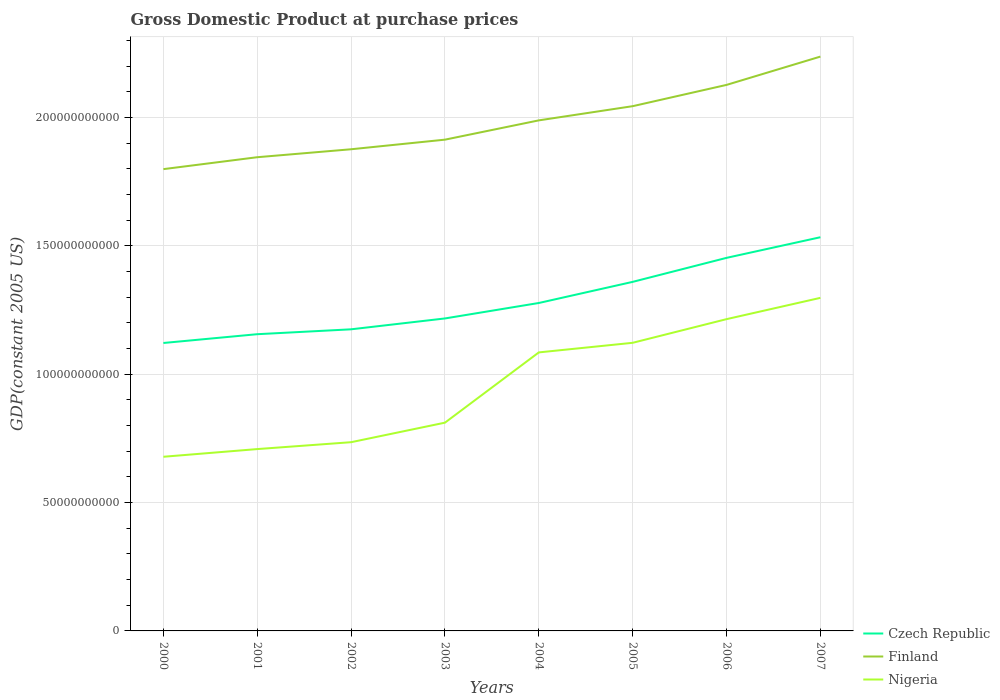How many different coloured lines are there?
Your answer should be compact. 3. Is the number of lines equal to the number of legend labels?
Keep it short and to the point. Yes. Across all years, what is the maximum GDP at purchase prices in Czech Republic?
Provide a short and direct response. 1.12e+11. In which year was the GDP at purchase prices in Nigeria maximum?
Give a very brief answer. 2000. What is the total GDP at purchase prices in Finland in the graph?
Offer a terse response. -3.24e+1. What is the difference between the highest and the second highest GDP at purchase prices in Nigeria?
Your response must be concise. 6.19e+1. Is the GDP at purchase prices in Czech Republic strictly greater than the GDP at purchase prices in Nigeria over the years?
Your answer should be very brief. No. How many lines are there?
Keep it short and to the point. 3. What is the difference between two consecutive major ticks on the Y-axis?
Offer a terse response. 5.00e+1. Are the values on the major ticks of Y-axis written in scientific E-notation?
Your answer should be very brief. No. Does the graph contain grids?
Offer a terse response. Yes. Where does the legend appear in the graph?
Ensure brevity in your answer.  Bottom right. How are the legend labels stacked?
Your response must be concise. Vertical. What is the title of the graph?
Provide a short and direct response. Gross Domestic Product at purchase prices. What is the label or title of the Y-axis?
Give a very brief answer. GDP(constant 2005 US). What is the GDP(constant 2005 US) of Czech Republic in 2000?
Provide a succinct answer. 1.12e+11. What is the GDP(constant 2005 US) of Finland in 2000?
Ensure brevity in your answer.  1.80e+11. What is the GDP(constant 2005 US) of Nigeria in 2000?
Keep it short and to the point. 6.79e+1. What is the GDP(constant 2005 US) of Czech Republic in 2001?
Ensure brevity in your answer.  1.16e+11. What is the GDP(constant 2005 US) of Finland in 2001?
Your answer should be compact. 1.85e+11. What is the GDP(constant 2005 US) in Nigeria in 2001?
Offer a very short reply. 7.08e+1. What is the GDP(constant 2005 US) of Czech Republic in 2002?
Offer a terse response. 1.18e+11. What is the GDP(constant 2005 US) of Finland in 2002?
Give a very brief answer. 1.88e+11. What is the GDP(constant 2005 US) of Nigeria in 2002?
Ensure brevity in your answer.  7.35e+1. What is the GDP(constant 2005 US) in Czech Republic in 2003?
Offer a very short reply. 1.22e+11. What is the GDP(constant 2005 US) in Finland in 2003?
Your answer should be compact. 1.91e+11. What is the GDP(constant 2005 US) in Nigeria in 2003?
Your answer should be compact. 8.11e+1. What is the GDP(constant 2005 US) in Czech Republic in 2004?
Ensure brevity in your answer.  1.28e+11. What is the GDP(constant 2005 US) of Finland in 2004?
Make the answer very short. 1.99e+11. What is the GDP(constant 2005 US) of Nigeria in 2004?
Your answer should be very brief. 1.09e+11. What is the GDP(constant 2005 US) in Czech Republic in 2005?
Provide a succinct answer. 1.36e+11. What is the GDP(constant 2005 US) of Finland in 2005?
Your answer should be compact. 2.04e+11. What is the GDP(constant 2005 US) of Nigeria in 2005?
Offer a very short reply. 1.12e+11. What is the GDP(constant 2005 US) in Czech Republic in 2006?
Provide a short and direct response. 1.45e+11. What is the GDP(constant 2005 US) of Finland in 2006?
Your response must be concise. 2.13e+11. What is the GDP(constant 2005 US) of Nigeria in 2006?
Ensure brevity in your answer.  1.21e+11. What is the GDP(constant 2005 US) of Czech Republic in 2007?
Keep it short and to the point. 1.53e+11. What is the GDP(constant 2005 US) in Finland in 2007?
Provide a succinct answer. 2.24e+11. What is the GDP(constant 2005 US) of Nigeria in 2007?
Provide a succinct answer. 1.30e+11. Across all years, what is the maximum GDP(constant 2005 US) in Czech Republic?
Make the answer very short. 1.53e+11. Across all years, what is the maximum GDP(constant 2005 US) in Finland?
Keep it short and to the point. 2.24e+11. Across all years, what is the maximum GDP(constant 2005 US) of Nigeria?
Ensure brevity in your answer.  1.30e+11. Across all years, what is the minimum GDP(constant 2005 US) in Czech Republic?
Provide a succinct answer. 1.12e+11. Across all years, what is the minimum GDP(constant 2005 US) in Finland?
Offer a terse response. 1.80e+11. Across all years, what is the minimum GDP(constant 2005 US) in Nigeria?
Keep it short and to the point. 6.79e+1. What is the total GDP(constant 2005 US) of Czech Republic in the graph?
Provide a short and direct response. 1.03e+12. What is the total GDP(constant 2005 US) of Finland in the graph?
Provide a succinct answer. 1.58e+12. What is the total GDP(constant 2005 US) of Nigeria in the graph?
Offer a very short reply. 7.65e+11. What is the difference between the GDP(constant 2005 US) of Czech Republic in 2000 and that in 2001?
Your answer should be very brief. -3.42e+09. What is the difference between the GDP(constant 2005 US) of Finland in 2000 and that in 2001?
Make the answer very short. -4.64e+09. What is the difference between the GDP(constant 2005 US) in Nigeria in 2000 and that in 2001?
Give a very brief answer. -2.99e+09. What is the difference between the GDP(constant 2005 US) of Czech Republic in 2000 and that in 2002?
Provide a short and direct response. -5.33e+09. What is the difference between the GDP(constant 2005 US) of Finland in 2000 and that in 2002?
Make the answer very short. -7.74e+09. What is the difference between the GDP(constant 2005 US) in Nigeria in 2000 and that in 2002?
Provide a succinct answer. -5.67e+09. What is the difference between the GDP(constant 2005 US) of Czech Republic in 2000 and that in 2003?
Give a very brief answer. -9.56e+09. What is the difference between the GDP(constant 2005 US) of Finland in 2000 and that in 2003?
Offer a very short reply. -1.15e+1. What is the difference between the GDP(constant 2005 US) in Nigeria in 2000 and that in 2003?
Keep it short and to the point. -1.33e+1. What is the difference between the GDP(constant 2005 US) in Czech Republic in 2000 and that in 2004?
Provide a short and direct response. -1.56e+1. What is the difference between the GDP(constant 2005 US) of Finland in 2000 and that in 2004?
Keep it short and to the point. -1.90e+1. What is the difference between the GDP(constant 2005 US) of Nigeria in 2000 and that in 2004?
Your answer should be very brief. -4.07e+1. What is the difference between the GDP(constant 2005 US) of Czech Republic in 2000 and that in 2005?
Your answer should be compact. -2.38e+1. What is the difference between the GDP(constant 2005 US) in Finland in 2000 and that in 2005?
Ensure brevity in your answer.  -2.45e+1. What is the difference between the GDP(constant 2005 US) of Nigeria in 2000 and that in 2005?
Provide a short and direct response. -4.44e+1. What is the difference between the GDP(constant 2005 US) in Czech Republic in 2000 and that in 2006?
Ensure brevity in your answer.  -3.32e+1. What is the difference between the GDP(constant 2005 US) of Finland in 2000 and that in 2006?
Offer a very short reply. -3.28e+1. What is the difference between the GDP(constant 2005 US) of Nigeria in 2000 and that in 2006?
Keep it short and to the point. -5.36e+1. What is the difference between the GDP(constant 2005 US) of Czech Republic in 2000 and that in 2007?
Offer a very short reply. -4.12e+1. What is the difference between the GDP(constant 2005 US) in Finland in 2000 and that in 2007?
Your answer should be compact. -4.38e+1. What is the difference between the GDP(constant 2005 US) of Nigeria in 2000 and that in 2007?
Your response must be concise. -6.19e+1. What is the difference between the GDP(constant 2005 US) of Czech Republic in 2001 and that in 2002?
Keep it short and to the point. -1.90e+09. What is the difference between the GDP(constant 2005 US) in Finland in 2001 and that in 2002?
Provide a short and direct response. -3.10e+09. What is the difference between the GDP(constant 2005 US) of Nigeria in 2001 and that in 2002?
Ensure brevity in your answer.  -2.68e+09. What is the difference between the GDP(constant 2005 US) in Czech Republic in 2001 and that in 2003?
Offer a terse response. -6.14e+09. What is the difference between the GDP(constant 2005 US) of Finland in 2001 and that in 2003?
Ensure brevity in your answer.  -6.84e+09. What is the difference between the GDP(constant 2005 US) of Nigeria in 2001 and that in 2003?
Provide a succinct answer. -1.03e+1. What is the difference between the GDP(constant 2005 US) of Czech Republic in 2001 and that in 2004?
Offer a terse response. -1.22e+1. What is the difference between the GDP(constant 2005 US) in Finland in 2001 and that in 2004?
Make the answer very short. -1.44e+1. What is the difference between the GDP(constant 2005 US) in Nigeria in 2001 and that in 2004?
Ensure brevity in your answer.  -3.77e+1. What is the difference between the GDP(constant 2005 US) of Czech Republic in 2001 and that in 2005?
Your answer should be compact. -2.04e+1. What is the difference between the GDP(constant 2005 US) in Finland in 2001 and that in 2005?
Your response must be concise. -1.99e+1. What is the difference between the GDP(constant 2005 US) of Nigeria in 2001 and that in 2005?
Keep it short and to the point. -4.14e+1. What is the difference between the GDP(constant 2005 US) of Czech Republic in 2001 and that in 2006?
Ensure brevity in your answer.  -2.97e+1. What is the difference between the GDP(constant 2005 US) in Finland in 2001 and that in 2006?
Offer a very short reply. -2.82e+1. What is the difference between the GDP(constant 2005 US) of Nigeria in 2001 and that in 2006?
Offer a very short reply. -5.06e+1. What is the difference between the GDP(constant 2005 US) of Czech Republic in 2001 and that in 2007?
Make the answer very short. -3.78e+1. What is the difference between the GDP(constant 2005 US) in Finland in 2001 and that in 2007?
Ensure brevity in your answer.  -3.92e+1. What is the difference between the GDP(constant 2005 US) of Nigeria in 2001 and that in 2007?
Your answer should be very brief. -5.89e+1. What is the difference between the GDP(constant 2005 US) of Czech Republic in 2002 and that in 2003?
Make the answer very short. -4.23e+09. What is the difference between the GDP(constant 2005 US) of Finland in 2002 and that in 2003?
Provide a succinct answer. -3.74e+09. What is the difference between the GDP(constant 2005 US) in Nigeria in 2002 and that in 2003?
Provide a succinct answer. -7.61e+09. What is the difference between the GDP(constant 2005 US) of Czech Republic in 2002 and that in 2004?
Provide a short and direct response. -1.03e+1. What is the difference between the GDP(constant 2005 US) of Finland in 2002 and that in 2004?
Offer a terse response. -1.13e+1. What is the difference between the GDP(constant 2005 US) of Nigeria in 2002 and that in 2004?
Make the answer very short. -3.50e+1. What is the difference between the GDP(constant 2005 US) in Czech Republic in 2002 and that in 2005?
Provide a short and direct response. -1.85e+1. What is the difference between the GDP(constant 2005 US) in Finland in 2002 and that in 2005?
Offer a very short reply. -1.68e+1. What is the difference between the GDP(constant 2005 US) of Nigeria in 2002 and that in 2005?
Make the answer very short. -3.87e+1. What is the difference between the GDP(constant 2005 US) of Czech Republic in 2002 and that in 2006?
Keep it short and to the point. -2.78e+1. What is the difference between the GDP(constant 2005 US) in Finland in 2002 and that in 2006?
Give a very brief answer. -2.51e+1. What is the difference between the GDP(constant 2005 US) in Nigeria in 2002 and that in 2006?
Your response must be concise. -4.79e+1. What is the difference between the GDP(constant 2005 US) in Czech Republic in 2002 and that in 2007?
Your answer should be compact. -3.59e+1. What is the difference between the GDP(constant 2005 US) of Finland in 2002 and that in 2007?
Ensure brevity in your answer.  -3.61e+1. What is the difference between the GDP(constant 2005 US) in Nigeria in 2002 and that in 2007?
Offer a very short reply. -5.62e+1. What is the difference between the GDP(constant 2005 US) in Czech Republic in 2003 and that in 2004?
Provide a short and direct response. -6.02e+09. What is the difference between the GDP(constant 2005 US) in Finland in 2003 and that in 2004?
Your response must be concise. -7.51e+09. What is the difference between the GDP(constant 2005 US) in Nigeria in 2003 and that in 2004?
Your response must be concise. -2.74e+1. What is the difference between the GDP(constant 2005 US) in Czech Republic in 2003 and that in 2005?
Keep it short and to the point. -1.43e+1. What is the difference between the GDP(constant 2005 US) in Finland in 2003 and that in 2005?
Your response must be concise. -1.30e+1. What is the difference between the GDP(constant 2005 US) of Nigeria in 2003 and that in 2005?
Your response must be concise. -3.11e+1. What is the difference between the GDP(constant 2005 US) in Czech Republic in 2003 and that in 2006?
Provide a short and direct response. -2.36e+1. What is the difference between the GDP(constant 2005 US) in Finland in 2003 and that in 2006?
Your answer should be compact. -2.13e+1. What is the difference between the GDP(constant 2005 US) in Nigeria in 2003 and that in 2006?
Provide a short and direct response. -4.03e+1. What is the difference between the GDP(constant 2005 US) in Czech Republic in 2003 and that in 2007?
Offer a very short reply. -3.16e+1. What is the difference between the GDP(constant 2005 US) in Finland in 2003 and that in 2007?
Offer a terse response. -3.24e+1. What is the difference between the GDP(constant 2005 US) in Nigeria in 2003 and that in 2007?
Make the answer very short. -4.86e+1. What is the difference between the GDP(constant 2005 US) of Czech Republic in 2004 and that in 2005?
Your answer should be compact. -8.23e+09. What is the difference between the GDP(constant 2005 US) of Finland in 2004 and that in 2005?
Provide a short and direct response. -5.53e+09. What is the difference between the GDP(constant 2005 US) of Nigeria in 2004 and that in 2005?
Your answer should be very brief. -3.74e+09. What is the difference between the GDP(constant 2005 US) of Czech Republic in 2004 and that in 2006?
Ensure brevity in your answer.  -1.76e+1. What is the difference between the GDP(constant 2005 US) in Finland in 2004 and that in 2006?
Make the answer very short. -1.38e+1. What is the difference between the GDP(constant 2005 US) in Nigeria in 2004 and that in 2006?
Keep it short and to the point. -1.30e+1. What is the difference between the GDP(constant 2005 US) of Czech Republic in 2004 and that in 2007?
Give a very brief answer. -2.56e+1. What is the difference between the GDP(constant 2005 US) in Finland in 2004 and that in 2007?
Your response must be concise. -2.48e+1. What is the difference between the GDP(constant 2005 US) in Nigeria in 2004 and that in 2007?
Your response must be concise. -2.12e+1. What is the difference between the GDP(constant 2005 US) in Czech Republic in 2005 and that in 2006?
Ensure brevity in your answer.  -9.35e+09. What is the difference between the GDP(constant 2005 US) of Finland in 2005 and that in 2006?
Provide a succinct answer. -8.29e+09. What is the difference between the GDP(constant 2005 US) of Nigeria in 2005 and that in 2006?
Your response must be concise. -9.22e+09. What is the difference between the GDP(constant 2005 US) of Czech Republic in 2005 and that in 2007?
Offer a very short reply. -1.74e+1. What is the difference between the GDP(constant 2005 US) in Finland in 2005 and that in 2007?
Your response must be concise. -1.93e+1. What is the difference between the GDP(constant 2005 US) in Nigeria in 2005 and that in 2007?
Provide a short and direct response. -1.75e+1. What is the difference between the GDP(constant 2005 US) of Czech Republic in 2006 and that in 2007?
Offer a terse response. -8.04e+09. What is the difference between the GDP(constant 2005 US) of Finland in 2006 and that in 2007?
Give a very brief answer. -1.10e+1. What is the difference between the GDP(constant 2005 US) in Nigeria in 2006 and that in 2007?
Give a very brief answer. -8.29e+09. What is the difference between the GDP(constant 2005 US) in Czech Republic in 2000 and the GDP(constant 2005 US) in Finland in 2001?
Give a very brief answer. -7.24e+1. What is the difference between the GDP(constant 2005 US) in Czech Republic in 2000 and the GDP(constant 2005 US) in Nigeria in 2001?
Your answer should be very brief. 4.13e+1. What is the difference between the GDP(constant 2005 US) of Finland in 2000 and the GDP(constant 2005 US) of Nigeria in 2001?
Offer a very short reply. 1.09e+11. What is the difference between the GDP(constant 2005 US) in Czech Republic in 2000 and the GDP(constant 2005 US) in Finland in 2002?
Give a very brief answer. -7.55e+1. What is the difference between the GDP(constant 2005 US) of Czech Republic in 2000 and the GDP(constant 2005 US) of Nigeria in 2002?
Give a very brief answer. 3.87e+1. What is the difference between the GDP(constant 2005 US) in Finland in 2000 and the GDP(constant 2005 US) in Nigeria in 2002?
Provide a short and direct response. 1.06e+11. What is the difference between the GDP(constant 2005 US) in Czech Republic in 2000 and the GDP(constant 2005 US) in Finland in 2003?
Ensure brevity in your answer.  -7.92e+1. What is the difference between the GDP(constant 2005 US) of Czech Republic in 2000 and the GDP(constant 2005 US) of Nigeria in 2003?
Your answer should be very brief. 3.10e+1. What is the difference between the GDP(constant 2005 US) in Finland in 2000 and the GDP(constant 2005 US) in Nigeria in 2003?
Your answer should be very brief. 9.88e+1. What is the difference between the GDP(constant 2005 US) of Czech Republic in 2000 and the GDP(constant 2005 US) of Finland in 2004?
Your answer should be compact. -8.67e+1. What is the difference between the GDP(constant 2005 US) in Czech Republic in 2000 and the GDP(constant 2005 US) in Nigeria in 2004?
Ensure brevity in your answer.  3.67e+09. What is the difference between the GDP(constant 2005 US) in Finland in 2000 and the GDP(constant 2005 US) in Nigeria in 2004?
Your response must be concise. 7.14e+1. What is the difference between the GDP(constant 2005 US) of Czech Republic in 2000 and the GDP(constant 2005 US) of Finland in 2005?
Offer a very short reply. -9.23e+1. What is the difference between the GDP(constant 2005 US) in Czech Republic in 2000 and the GDP(constant 2005 US) in Nigeria in 2005?
Keep it short and to the point. -7.09e+07. What is the difference between the GDP(constant 2005 US) of Finland in 2000 and the GDP(constant 2005 US) of Nigeria in 2005?
Your answer should be very brief. 6.77e+1. What is the difference between the GDP(constant 2005 US) in Czech Republic in 2000 and the GDP(constant 2005 US) in Finland in 2006?
Your answer should be compact. -1.01e+11. What is the difference between the GDP(constant 2005 US) in Czech Republic in 2000 and the GDP(constant 2005 US) in Nigeria in 2006?
Your response must be concise. -9.29e+09. What is the difference between the GDP(constant 2005 US) of Finland in 2000 and the GDP(constant 2005 US) of Nigeria in 2006?
Your response must be concise. 5.84e+1. What is the difference between the GDP(constant 2005 US) in Czech Republic in 2000 and the GDP(constant 2005 US) in Finland in 2007?
Your answer should be compact. -1.12e+11. What is the difference between the GDP(constant 2005 US) in Czech Republic in 2000 and the GDP(constant 2005 US) in Nigeria in 2007?
Your answer should be very brief. -1.76e+1. What is the difference between the GDP(constant 2005 US) of Finland in 2000 and the GDP(constant 2005 US) of Nigeria in 2007?
Provide a succinct answer. 5.01e+1. What is the difference between the GDP(constant 2005 US) in Czech Republic in 2001 and the GDP(constant 2005 US) in Finland in 2002?
Keep it short and to the point. -7.21e+1. What is the difference between the GDP(constant 2005 US) of Czech Republic in 2001 and the GDP(constant 2005 US) of Nigeria in 2002?
Offer a terse response. 4.21e+1. What is the difference between the GDP(constant 2005 US) of Finland in 2001 and the GDP(constant 2005 US) of Nigeria in 2002?
Offer a very short reply. 1.11e+11. What is the difference between the GDP(constant 2005 US) of Czech Republic in 2001 and the GDP(constant 2005 US) of Finland in 2003?
Offer a terse response. -7.58e+1. What is the difference between the GDP(constant 2005 US) in Czech Republic in 2001 and the GDP(constant 2005 US) in Nigeria in 2003?
Offer a terse response. 3.45e+1. What is the difference between the GDP(constant 2005 US) of Finland in 2001 and the GDP(constant 2005 US) of Nigeria in 2003?
Your response must be concise. 1.03e+11. What is the difference between the GDP(constant 2005 US) in Czech Republic in 2001 and the GDP(constant 2005 US) in Finland in 2004?
Your response must be concise. -8.33e+1. What is the difference between the GDP(constant 2005 US) in Czech Republic in 2001 and the GDP(constant 2005 US) in Nigeria in 2004?
Make the answer very short. 7.09e+09. What is the difference between the GDP(constant 2005 US) in Finland in 2001 and the GDP(constant 2005 US) in Nigeria in 2004?
Keep it short and to the point. 7.60e+1. What is the difference between the GDP(constant 2005 US) of Czech Republic in 2001 and the GDP(constant 2005 US) of Finland in 2005?
Provide a succinct answer. -8.88e+1. What is the difference between the GDP(constant 2005 US) of Czech Republic in 2001 and the GDP(constant 2005 US) of Nigeria in 2005?
Offer a terse response. 3.35e+09. What is the difference between the GDP(constant 2005 US) of Finland in 2001 and the GDP(constant 2005 US) of Nigeria in 2005?
Offer a terse response. 7.23e+1. What is the difference between the GDP(constant 2005 US) of Czech Republic in 2001 and the GDP(constant 2005 US) of Finland in 2006?
Offer a terse response. -9.71e+1. What is the difference between the GDP(constant 2005 US) of Czech Republic in 2001 and the GDP(constant 2005 US) of Nigeria in 2006?
Your answer should be compact. -5.86e+09. What is the difference between the GDP(constant 2005 US) of Finland in 2001 and the GDP(constant 2005 US) of Nigeria in 2006?
Offer a very short reply. 6.31e+1. What is the difference between the GDP(constant 2005 US) in Czech Republic in 2001 and the GDP(constant 2005 US) in Finland in 2007?
Your answer should be very brief. -1.08e+11. What is the difference between the GDP(constant 2005 US) of Czech Republic in 2001 and the GDP(constant 2005 US) of Nigeria in 2007?
Offer a terse response. -1.42e+1. What is the difference between the GDP(constant 2005 US) in Finland in 2001 and the GDP(constant 2005 US) in Nigeria in 2007?
Ensure brevity in your answer.  5.48e+1. What is the difference between the GDP(constant 2005 US) in Czech Republic in 2002 and the GDP(constant 2005 US) in Finland in 2003?
Your response must be concise. -7.39e+1. What is the difference between the GDP(constant 2005 US) in Czech Republic in 2002 and the GDP(constant 2005 US) in Nigeria in 2003?
Give a very brief answer. 3.64e+1. What is the difference between the GDP(constant 2005 US) in Finland in 2002 and the GDP(constant 2005 US) in Nigeria in 2003?
Ensure brevity in your answer.  1.07e+11. What is the difference between the GDP(constant 2005 US) of Czech Republic in 2002 and the GDP(constant 2005 US) of Finland in 2004?
Provide a succinct answer. -8.14e+1. What is the difference between the GDP(constant 2005 US) in Czech Republic in 2002 and the GDP(constant 2005 US) in Nigeria in 2004?
Provide a short and direct response. 8.99e+09. What is the difference between the GDP(constant 2005 US) in Finland in 2002 and the GDP(constant 2005 US) in Nigeria in 2004?
Your answer should be compact. 7.91e+1. What is the difference between the GDP(constant 2005 US) of Czech Republic in 2002 and the GDP(constant 2005 US) of Finland in 2005?
Provide a short and direct response. -8.69e+1. What is the difference between the GDP(constant 2005 US) of Czech Republic in 2002 and the GDP(constant 2005 US) of Nigeria in 2005?
Ensure brevity in your answer.  5.26e+09. What is the difference between the GDP(constant 2005 US) in Finland in 2002 and the GDP(constant 2005 US) in Nigeria in 2005?
Ensure brevity in your answer.  7.54e+1. What is the difference between the GDP(constant 2005 US) of Czech Republic in 2002 and the GDP(constant 2005 US) of Finland in 2006?
Make the answer very short. -9.52e+1. What is the difference between the GDP(constant 2005 US) in Czech Republic in 2002 and the GDP(constant 2005 US) in Nigeria in 2006?
Offer a terse response. -3.96e+09. What is the difference between the GDP(constant 2005 US) of Finland in 2002 and the GDP(constant 2005 US) of Nigeria in 2006?
Ensure brevity in your answer.  6.62e+1. What is the difference between the GDP(constant 2005 US) in Czech Republic in 2002 and the GDP(constant 2005 US) in Finland in 2007?
Provide a short and direct response. -1.06e+11. What is the difference between the GDP(constant 2005 US) of Czech Republic in 2002 and the GDP(constant 2005 US) of Nigeria in 2007?
Provide a short and direct response. -1.23e+1. What is the difference between the GDP(constant 2005 US) of Finland in 2002 and the GDP(constant 2005 US) of Nigeria in 2007?
Keep it short and to the point. 5.79e+1. What is the difference between the GDP(constant 2005 US) in Czech Republic in 2003 and the GDP(constant 2005 US) in Finland in 2004?
Your answer should be very brief. -7.72e+1. What is the difference between the GDP(constant 2005 US) of Czech Republic in 2003 and the GDP(constant 2005 US) of Nigeria in 2004?
Give a very brief answer. 1.32e+1. What is the difference between the GDP(constant 2005 US) in Finland in 2003 and the GDP(constant 2005 US) in Nigeria in 2004?
Your response must be concise. 8.29e+1. What is the difference between the GDP(constant 2005 US) in Czech Republic in 2003 and the GDP(constant 2005 US) in Finland in 2005?
Your response must be concise. -8.27e+1. What is the difference between the GDP(constant 2005 US) in Czech Republic in 2003 and the GDP(constant 2005 US) in Nigeria in 2005?
Keep it short and to the point. 9.49e+09. What is the difference between the GDP(constant 2005 US) in Finland in 2003 and the GDP(constant 2005 US) in Nigeria in 2005?
Your response must be concise. 7.91e+1. What is the difference between the GDP(constant 2005 US) of Czech Republic in 2003 and the GDP(constant 2005 US) of Finland in 2006?
Your answer should be very brief. -9.10e+1. What is the difference between the GDP(constant 2005 US) of Czech Republic in 2003 and the GDP(constant 2005 US) of Nigeria in 2006?
Offer a terse response. 2.72e+08. What is the difference between the GDP(constant 2005 US) in Finland in 2003 and the GDP(constant 2005 US) in Nigeria in 2006?
Your answer should be very brief. 6.99e+1. What is the difference between the GDP(constant 2005 US) of Czech Republic in 2003 and the GDP(constant 2005 US) of Finland in 2007?
Offer a terse response. -1.02e+11. What is the difference between the GDP(constant 2005 US) in Czech Republic in 2003 and the GDP(constant 2005 US) in Nigeria in 2007?
Give a very brief answer. -8.02e+09. What is the difference between the GDP(constant 2005 US) in Finland in 2003 and the GDP(constant 2005 US) in Nigeria in 2007?
Offer a very short reply. 6.16e+1. What is the difference between the GDP(constant 2005 US) of Czech Republic in 2004 and the GDP(constant 2005 US) of Finland in 2005?
Offer a terse response. -7.67e+1. What is the difference between the GDP(constant 2005 US) of Czech Republic in 2004 and the GDP(constant 2005 US) of Nigeria in 2005?
Offer a terse response. 1.55e+1. What is the difference between the GDP(constant 2005 US) in Finland in 2004 and the GDP(constant 2005 US) in Nigeria in 2005?
Ensure brevity in your answer.  8.67e+1. What is the difference between the GDP(constant 2005 US) of Czech Republic in 2004 and the GDP(constant 2005 US) of Finland in 2006?
Ensure brevity in your answer.  -8.50e+1. What is the difference between the GDP(constant 2005 US) of Czech Republic in 2004 and the GDP(constant 2005 US) of Nigeria in 2006?
Your response must be concise. 6.29e+09. What is the difference between the GDP(constant 2005 US) in Finland in 2004 and the GDP(constant 2005 US) in Nigeria in 2006?
Provide a short and direct response. 7.74e+1. What is the difference between the GDP(constant 2005 US) of Czech Republic in 2004 and the GDP(constant 2005 US) of Finland in 2007?
Make the answer very short. -9.60e+1. What is the difference between the GDP(constant 2005 US) of Czech Republic in 2004 and the GDP(constant 2005 US) of Nigeria in 2007?
Provide a succinct answer. -2.00e+09. What is the difference between the GDP(constant 2005 US) in Finland in 2004 and the GDP(constant 2005 US) in Nigeria in 2007?
Offer a very short reply. 6.91e+1. What is the difference between the GDP(constant 2005 US) of Czech Republic in 2005 and the GDP(constant 2005 US) of Finland in 2006?
Your answer should be very brief. -7.67e+1. What is the difference between the GDP(constant 2005 US) in Czech Republic in 2005 and the GDP(constant 2005 US) in Nigeria in 2006?
Provide a short and direct response. 1.45e+1. What is the difference between the GDP(constant 2005 US) in Finland in 2005 and the GDP(constant 2005 US) in Nigeria in 2006?
Give a very brief answer. 8.30e+1. What is the difference between the GDP(constant 2005 US) of Czech Republic in 2005 and the GDP(constant 2005 US) of Finland in 2007?
Offer a very short reply. -8.78e+1. What is the difference between the GDP(constant 2005 US) of Czech Republic in 2005 and the GDP(constant 2005 US) of Nigeria in 2007?
Provide a short and direct response. 6.23e+09. What is the difference between the GDP(constant 2005 US) in Finland in 2005 and the GDP(constant 2005 US) in Nigeria in 2007?
Offer a very short reply. 7.47e+1. What is the difference between the GDP(constant 2005 US) in Czech Republic in 2006 and the GDP(constant 2005 US) in Finland in 2007?
Your answer should be compact. -7.84e+1. What is the difference between the GDP(constant 2005 US) in Czech Republic in 2006 and the GDP(constant 2005 US) in Nigeria in 2007?
Provide a short and direct response. 1.56e+1. What is the difference between the GDP(constant 2005 US) in Finland in 2006 and the GDP(constant 2005 US) in Nigeria in 2007?
Provide a succinct answer. 8.30e+1. What is the average GDP(constant 2005 US) in Czech Republic per year?
Keep it short and to the point. 1.29e+11. What is the average GDP(constant 2005 US) of Finland per year?
Ensure brevity in your answer.  1.98e+11. What is the average GDP(constant 2005 US) in Nigeria per year?
Ensure brevity in your answer.  9.57e+1. In the year 2000, what is the difference between the GDP(constant 2005 US) of Czech Republic and GDP(constant 2005 US) of Finland?
Provide a succinct answer. -6.77e+1. In the year 2000, what is the difference between the GDP(constant 2005 US) of Czech Republic and GDP(constant 2005 US) of Nigeria?
Provide a succinct answer. 4.43e+1. In the year 2000, what is the difference between the GDP(constant 2005 US) of Finland and GDP(constant 2005 US) of Nigeria?
Make the answer very short. 1.12e+11. In the year 2001, what is the difference between the GDP(constant 2005 US) of Czech Republic and GDP(constant 2005 US) of Finland?
Your response must be concise. -6.89e+1. In the year 2001, what is the difference between the GDP(constant 2005 US) of Czech Republic and GDP(constant 2005 US) of Nigeria?
Offer a very short reply. 4.48e+1. In the year 2001, what is the difference between the GDP(constant 2005 US) in Finland and GDP(constant 2005 US) in Nigeria?
Your answer should be compact. 1.14e+11. In the year 2002, what is the difference between the GDP(constant 2005 US) in Czech Republic and GDP(constant 2005 US) in Finland?
Make the answer very short. -7.01e+1. In the year 2002, what is the difference between the GDP(constant 2005 US) in Czech Republic and GDP(constant 2005 US) in Nigeria?
Offer a very short reply. 4.40e+1. In the year 2002, what is the difference between the GDP(constant 2005 US) in Finland and GDP(constant 2005 US) in Nigeria?
Provide a succinct answer. 1.14e+11. In the year 2003, what is the difference between the GDP(constant 2005 US) of Czech Republic and GDP(constant 2005 US) of Finland?
Make the answer very short. -6.97e+1. In the year 2003, what is the difference between the GDP(constant 2005 US) in Czech Republic and GDP(constant 2005 US) in Nigeria?
Offer a very short reply. 4.06e+1. In the year 2003, what is the difference between the GDP(constant 2005 US) of Finland and GDP(constant 2005 US) of Nigeria?
Give a very brief answer. 1.10e+11. In the year 2004, what is the difference between the GDP(constant 2005 US) of Czech Republic and GDP(constant 2005 US) of Finland?
Your response must be concise. -7.11e+1. In the year 2004, what is the difference between the GDP(constant 2005 US) of Czech Republic and GDP(constant 2005 US) of Nigeria?
Provide a succinct answer. 1.92e+1. In the year 2004, what is the difference between the GDP(constant 2005 US) in Finland and GDP(constant 2005 US) in Nigeria?
Provide a short and direct response. 9.04e+1. In the year 2005, what is the difference between the GDP(constant 2005 US) in Czech Republic and GDP(constant 2005 US) in Finland?
Offer a terse response. -6.84e+1. In the year 2005, what is the difference between the GDP(constant 2005 US) in Czech Republic and GDP(constant 2005 US) in Nigeria?
Offer a very short reply. 2.37e+1. In the year 2005, what is the difference between the GDP(constant 2005 US) of Finland and GDP(constant 2005 US) of Nigeria?
Offer a terse response. 9.22e+1. In the year 2006, what is the difference between the GDP(constant 2005 US) of Czech Republic and GDP(constant 2005 US) of Finland?
Ensure brevity in your answer.  -6.74e+1. In the year 2006, what is the difference between the GDP(constant 2005 US) of Czech Republic and GDP(constant 2005 US) of Nigeria?
Ensure brevity in your answer.  2.39e+1. In the year 2006, what is the difference between the GDP(constant 2005 US) of Finland and GDP(constant 2005 US) of Nigeria?
Keep it short and to the point. 9.13e+1. In the year 2007, what is the difference between the GDP(constant 2005 US) of Czech Republic and GDP(constant 2005 US) of Finland?
Give a very brief answer. -7.04e+1. In the year 2007, what is the difference between the GDP(constant 2005 US) in Czech Republic and GDP(constant 2005 US) in Nigeria?
Keep it short and to the point. 2.36e+1. In the year 2007, what is the difference between the GDP(constant 2005 US) of Finland and GDP(constant 2005 US) of Nigeria?
Your answer should be very brief. 9.40e+1. What is the ratio of the GDP(constant 2005 US) of Czech Republic in 2000 to that in 2001?
Provide a short and direct response. 0.97. What is the ratio of the GDP(constant 2005 US) in Finland in 2000 to that in 2001?
Your answer should be very brief. 0.97. What is the ratio of the GDP(constant 2005 US) of Nigeria in 2000 to that in 2001?
Your response must be concise. 0.96. What is the ratio of the GDP(constant 2005 US) of Czech Republic in 2000 to that in 2002?
Provide a short and direct response. 0.95. What is the ratio of the GDP(constant 2005 US) of Finland in 2000 to that in 2002?
Give a very brief answer. 0.96. What is the ratio of the GDP(constant 2005 US) in Nigeria in 2000 to that in 2002?
Keep it short and to the point. 0.92. What is the ratio of the GDP(constant 2005 US) of Czech Republic in 2000 to that in 2003?
Make the answer very short. 0.92. What is the ratio of the GDP(constant 2005 US) of Finland in 2000 to that in 2003?
Your answer should be very brief. 0.94. What is the ratio of the GDP(constant 2005 US) of Nigeria in 2000 to that in 2003?
Provide a short and direct response. 0.84. What is the ratio of the GDP(constant 2005 US) in Czech Republic in 2000 to that in 2004?
Offer a terse response. 0.88. What is the ratio of the GDP(constant 2005 US) in Finland in 2000 to that in 2004?
Your response must be concise. 0.9. What is the ratio of the GDP(constant 2005 US) of Nigeria in 2000 to that in 2004?
Your response must be concise. 0.63. What is the ratio of the GDP(constant 2005 US) in Czech Republic in 2000 to that in 2005?
Provide a short and direct response. 0.82. What is the ratio of the GDP(constant 2005 US) in Nigeria in 2000 to that in 2005?
Give a very brief answer. 0.6. What is the ratio of the GDP(constant 2005 US) in Czech Republic in 2000 to that in 2006?
Offer a very short reply. 0.77. What is the ratio of the GDP(constant 2005 US) in Finland in 2000 to that in 2006?
Make the answer very short. 0.85. What is the ratio of the GDP(constant 2005 US) of Nigeria in 2000 to that in 2006?
Offer a very short reply. 0.56. What is the ratio of the GDP(constant 2005 US) in Czech Republic in 2000 to that in 2007?
Provide a succinct answer. 0.73. What is the ratio of the GDP(constant 2005 US) of Finland in 2000 to that in 2007?
Provide a succinct answer. 0.8. What is the ratio of the GDP(constant 2005 US) in Nigeria in 2000 to that in 2007?
Your response must be concise. 0.52. What is the ratio of the GDP(constant 2005 US) of Czech Republic in 2001 to that in 2002?
Keep it short and to the point. 0.98. What is the ratio of the GDP(constant 2005 US) of Finland in 2001 to that in 2002?
Provide a succinct answer. 0.98. What is the ratio of the GDP(constant 2005 US) of Nigeria in 2001 to that in 2002?
Provide a short and direct response. 0.96. What is the ratio of the GDP(constant 2005 US) of Czech Republic in 2001 to that in 2003?
Your answer should be compact. 0.95. What is the ratio of the GDP(constant 2005 US) of Finland in 2001 to that in 2003?
Keep it short and to the point. 0.96. What is the ratio of the GDP(constant 2005 US) in Nigeria in 2001 to that in 2003?
Your answer should be very brief. 0.87. What is the ratio of the GDP(constant 2005 US) in Czech Republic in 2001 to that in 2004?
Offer a very short reply. 0.9. What is the ratio of the GDP(constant 2005 US) of Finland in 2001 to that in 2004?
Offer a terse response. 0.93. What is the ratio of the GDP(constant 2005 US) of Nigeria in 2001 to that in 2004?
Offer a terse response. 0.65. What is the ratio of the GDP(constant 2005 US) of Czech Republic in 2001 to that in 2005?
Keep it short and to the point. 0.85. What is the ratio of the GDP(constant 2005 US) of Finland in 2001 to that in 2005?
Keep it short and to the point. 0.9. What is the ratio of the GDP(constant 2005 US) of Nigeria in 2001 to that in 2005?
Give a very brief answer. 0.63. What is the ratio of the GDP(constant 2005 US) in Czech Republic in 2001 to that in 2006?
Your answer should be compact. 0.8. What is the ratio of the GDP(constant 2005 US) of Finland in 2001 to that in 2006?
Make the answer very short. 0.87. What is the ratio of the GDP(constant 2005 US) in Nigeria in 2001 to that in 2006?
Provide a succinct answer. 0.58. What is the ratio of the GDP(constant 2005 US) of Czech Republic in 2001 to that in 2007?
Keep it short and to the point. 0.75. What is the ratio of the GDP(constant 2005 US) of Finland in 2001 to that in 2007?
Make the answer very short. 0.82. What is the ratio of the GDP(constant 2005 US) in Nigeria in 2001 to that in 2007?
Keep it short and to the point. 0.55. What is the ratio of the GDP(constant 2005 US) in Czech Republic in 2002 to that in 2003?
Your answer should be compact. 0.97. What is the ratio of the GDP(constant 2005 US) of Finland in 2002 to that in 2003?
Your answer should be compact. 0.98. What is the ratio of the GDP(constant 2005 US) in Nigeria in 2002 to that in 2003?
Provide a succinct answer. 0.91. What is the ratio of the GDP(constant 2005 US) of Czech Republic in 2002 to that in 2004?
Give a very brief answer. 0.92. What is the ratio of the GDP(constant 2005 US) of Finland in 2002 to that in 2004?
Offer a terse response. 0.94. What is the ratio of the GDP(constant 2005 US) in Nigeria in 2002 to that in 2004?
Offer a terse response. 0.68. What is the ratio of the GDP(constant 2005 US) in Czech Republic in 2002 to that in 2005?
Your response must be concise. 0.86. What is the ratio of the GDP(constant 2005 US) in Finland in 2002 to that in 2005?
Your response must be concise. 0.92. What is the ratio of the GDP(constant 2005 US) in Nigeria in 2002 to that in 2005?
Your response must be concise. 0.66. What is the ratio of the GDP(constant 2005 US) of Czech Republic in 2002 to that in 2006?
Offer a very short reply. 0.81. What is the ratio of the GDP(constant 2005 US) in Finland in 2002 to that in 2006?
Offer a terse response. 0.88. What is the ratio of the GDP(constant 2005 US) in Nigeria in 2002 to that in 2006?
Make the answer very short. 0.61. What is the ratio of the GDP(constant 2005 US) of Czech Republic in 2002 to that in 2007?
Keep it short and to the point. 0.77. What is the ratio of the GDP(constant 2005 US) of Finland in 2002 to that in 2007?
Make the answer very short. 0.84. What is the ratio of the GDP(constant 2005 US) of Nigeria in 2002 to that in 2007?
Your answer should be very brief. 0.57. What is the ratio of the GDP(constant 2005 US) in Czech Republic in 2003 to that in 2004?
Your response must be concise. 0.95. What is the ratio of the GDP(constant 2005 US) in Finland in 2003 to that in 2004?
Offer a terse response. 0.96. What is the ratio of the GDP(constant 2005 US) of Nigeria in 2003 to that in 2004?
Your answer should be very brief. 0.75. What is the ratio of the GDP(constant 2005 US) of Czech Republic in 2003 to that in 2005?
Provide a succinct answer. 0.9. What is the ratio of the GDP(constant 2005 US) in Finland in 2003 to that in 2005?
Keep it short and to the point. 0.94. What is the ratio of the GDP(constant 2005 US) in Nigeria in 2003 to that in 2005?
Ensure brevity in your answer.  0.72. What is the ratio of the GDP(constant 2005 US) in Czech Republic in 2003 to that in 2006?
Your answer should be very brief. 0.84. What is the ratio of the GDP(constant 2005 US) of Finland in 2003 to that in 2006?
Offer a terse response. 0.9. What is the ratio of the GDP(constant 2005 US) in Nigeria in 2003 to that in 2006?
Make the answer very short. 0.67. What is the ratio of the GDP(constant 2005 US) in Czech Republic in 2003 to that in 2007?
Your answer should be very brief. 0.79. What is the ratio of the GDP(constant 2005 US) of Finland in 2003 to that in 2007?
Offer a terse response. 0.86. What is the ratio of the GDP(constant 2005 US) of Nigeria in 2003 to that in 2007?
Your answer should be very brief. 0.63. What is the ratio of the GDP(constant 2005 US) of Czech Republic in 2004 to that in 2005?
Give a very brief answer. 0.94. What is the ratio of the GDP(constant 2005 US) in Nigeria in 2004 to that in 2005?
Ensure brevity in your answer.  0.97. What is the ratio of the GDP(constant 2005 US) in Czech Republic in 2004 to that in 2006?
Ensure brevity in your answer.  0.88. What is the ratio of the GDP(constant 2005 US) of Finland in 2004 to that in 2006?
Your answer should be compact. 0.94. What is the ratio of the GDP(constant 2005 US) of Nigeria in 2004 to that in 2006?
Offer a terse response. 0.89. What is the ratio of the GDP(constant 2005 US) in Czech Republic in 2004 to that in 2007?
Your response must be concise. 0.83. What is the ratio of the GDP(constant 2005 US) in Finland in 2004 to that in 2007?
Your response must be concise. 0.89. What is the ratio of the GDP(constant 2005 US) in Nigeria in 2004 to that in 2007?
Keep it short and to the point. 0.84. What is the ratio of the GDP(constant 2005 US) of Czech Republic in 2005 to that in 2006?
Your response must be concise. 0.94. What is the ratio of the GDP(constant 2005 US) in Nigeria in 2005 to that in 2006?
Offer a very short reply. 0.92. What is the ratio of the GDP(constant 2005 US) in Czech Republic in 2005 to that in 2007?
Offer a very short reply. 0.89. What is the ratio of the GDP(constant 2005 US) of Finland in 2005 to that in 2007?
Provide a short and direct response. 0.91. What is the ratio of the GDP(constant 2005 US) of Nigeria in 2005 to that in 2007?
Keep it short and to the point. 0.87. What is the ratio of the GDP(constant 2005 US) of Czech Republic in 2006 to that in 2007?
Make the answer very short. 0.95. What is the ratio of the GDP(constant 2005 US) of Finland in 2006 to that in 2007?
Offer a terse response. 0.95. What is the ratio of the GDP(constant 2005 US) in Nigeria in 2006 to that in 2007?
Make the answer very short. 0.94. What is the difference between the highest and the second highest GDP(constant 2005 US) in Czech Republic?
Your response must be concise. 8.04e+09. What is the difference between the highest and the second highest GDP(constant 2005 US) of Finland?
Give a very brief answer. 1.10e+1. What is the difference between the highest and the second highest GDP(constant 2005 US) of Nigeria?
Keep it short and to the point. 8.29e+09. What is the difference between the highest and the lowest GDP(constant 2005 US) of Czech Republic?
Make the answer very short. 4.12e+1. What is the difference between the highest and the lowest GDP(constant 2005 US) in Finland?
Provide a short and direct response. 4.38e+1. What is the difference between the highest and the lowest GDP(constant 2005 US) in Nigeria?
Your response must be concise. 6.19e+1. 